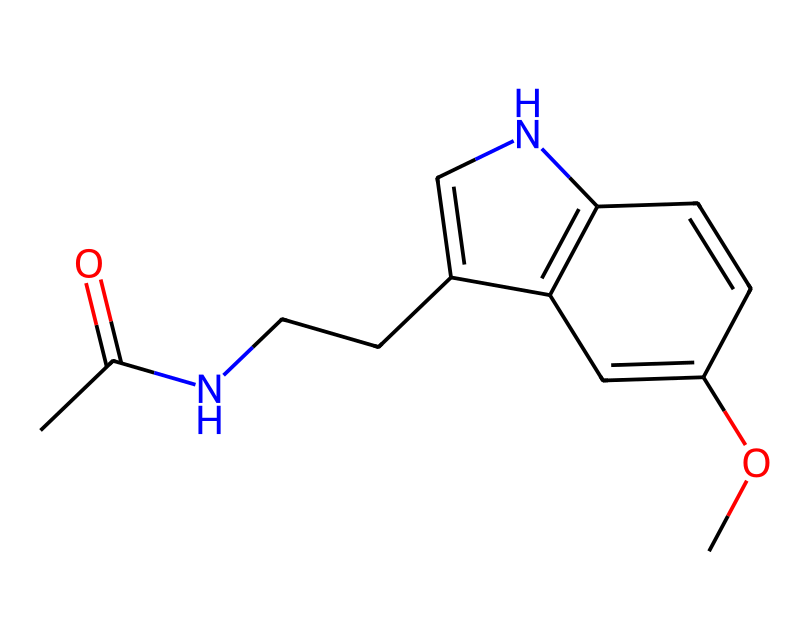What is the molecular formula for this chemical? The molecular formula can be determined by counting the number of each type of atom present in the structure based on the provided SMILES notation. The specific atoms in the structure include carbon (C), hydrogen (H), oxygen (O), and nitrogen (N). By counting the atoms, we find there are 12 carbons, 15 hydrogens, 1 oxygen, and 1 nitrogen, resulting in the molecular formula C12H15N1O1.
Answer: C12H15NO How many rings are present in this chemical structure? By analyzing the given SMILES, we can identify rings by looking for characters '1' which indicate ring closures. In this chemical structure, there are two occurrences of '1' indicating one complete cyclic structure, thus there is one ring present.
Answer: 1 ring What type of drug is this compound classified as? Referring to the chemical's structure, notably the presence of a nitrogen atom and its functionality reflective of sleep regulation, it is classified primarily as a melatonin analog and thus classified as a sleep aid.
Answer: sleep aid Does this chemical contain any functional groups? By analyzing the bonds and connections within the chemical structure, we can identify the presence of functional groups such as an amide (the -C(=O)N-) and a methoxy (-OCH3) group. Both of these groups play significant roles in the biological activity of the compound.
Answer: yes What is the effect of this chemical on sleep patterns? The overall structure aligns with that of melatonin, a hormone that regulates sleep cycles. The presence of molecular components that mimic melatonin suggests this compound may similarly promote sleep onset and regulate sleep-wake cycles, especially relevant in the context of travel or shift disruptions.
Answer: regulates sleep patterns Does this compound include heteroatoms? To answer this, we need to assess the structure for non-carbon, non-hydrogen atoms. Upon examination, we find the presence of nitrogen (N) and oxygen (O) atoms, confirming that this compound does indeed contain heteroatoms.
Answer: yes 